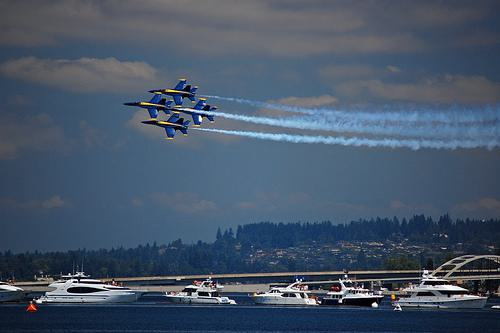How many boats are there in the image? There are numerous boats visible in the image. They seem to be gathered on the water to watch an event, possibly an air show, as indicated by the formation of jets flying overhead with blue and white smoke trails. 